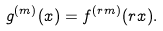Convert formula to latex. <formula><loc_0><loc_0><loc_500><loc_500>g ^ { ( m ) } ( x ) = f ^ { ( r m ) } ( r x ) .</formula> 